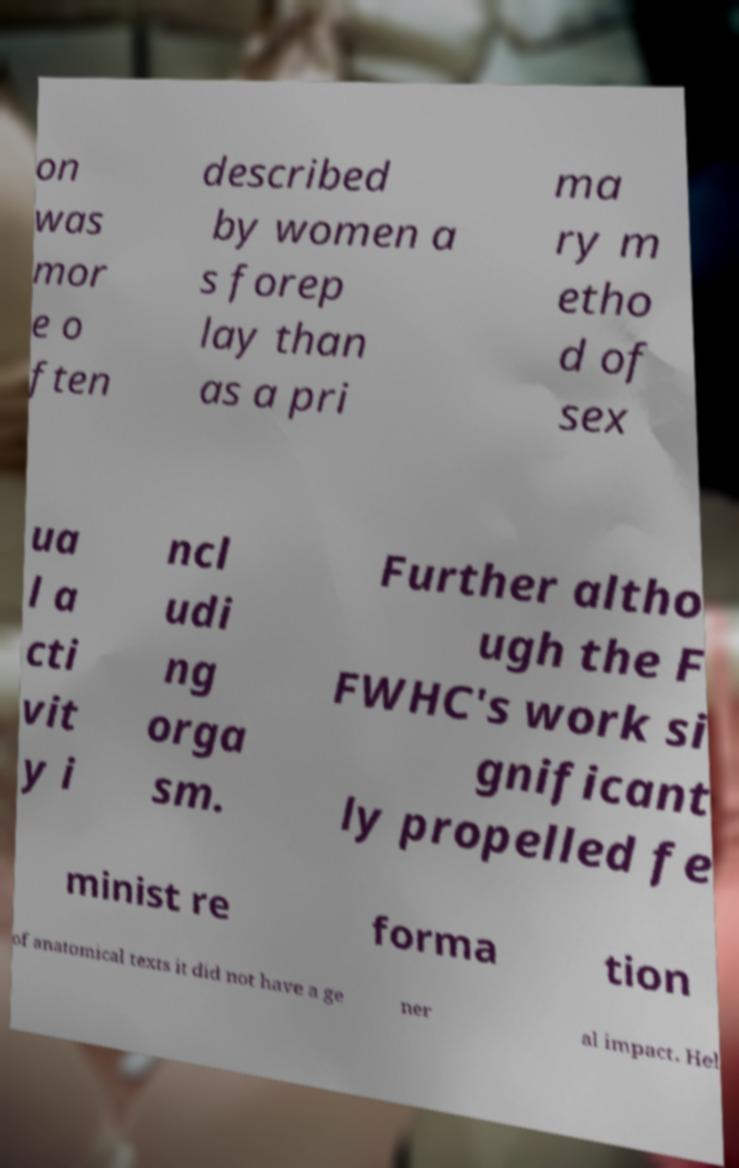Can you accurately transcribe the text from the provided image for me? on was mor e o ften described by women a s forep lay than as a pri ma ry m etho d of sex ua l a cti vit y i ncl udi ng orga sm. Further altho ugh the F FWHC's work si gnificant ly propelled fe minist re forma tion of anatomical texts it did not have a ge ner al impact. Hel 